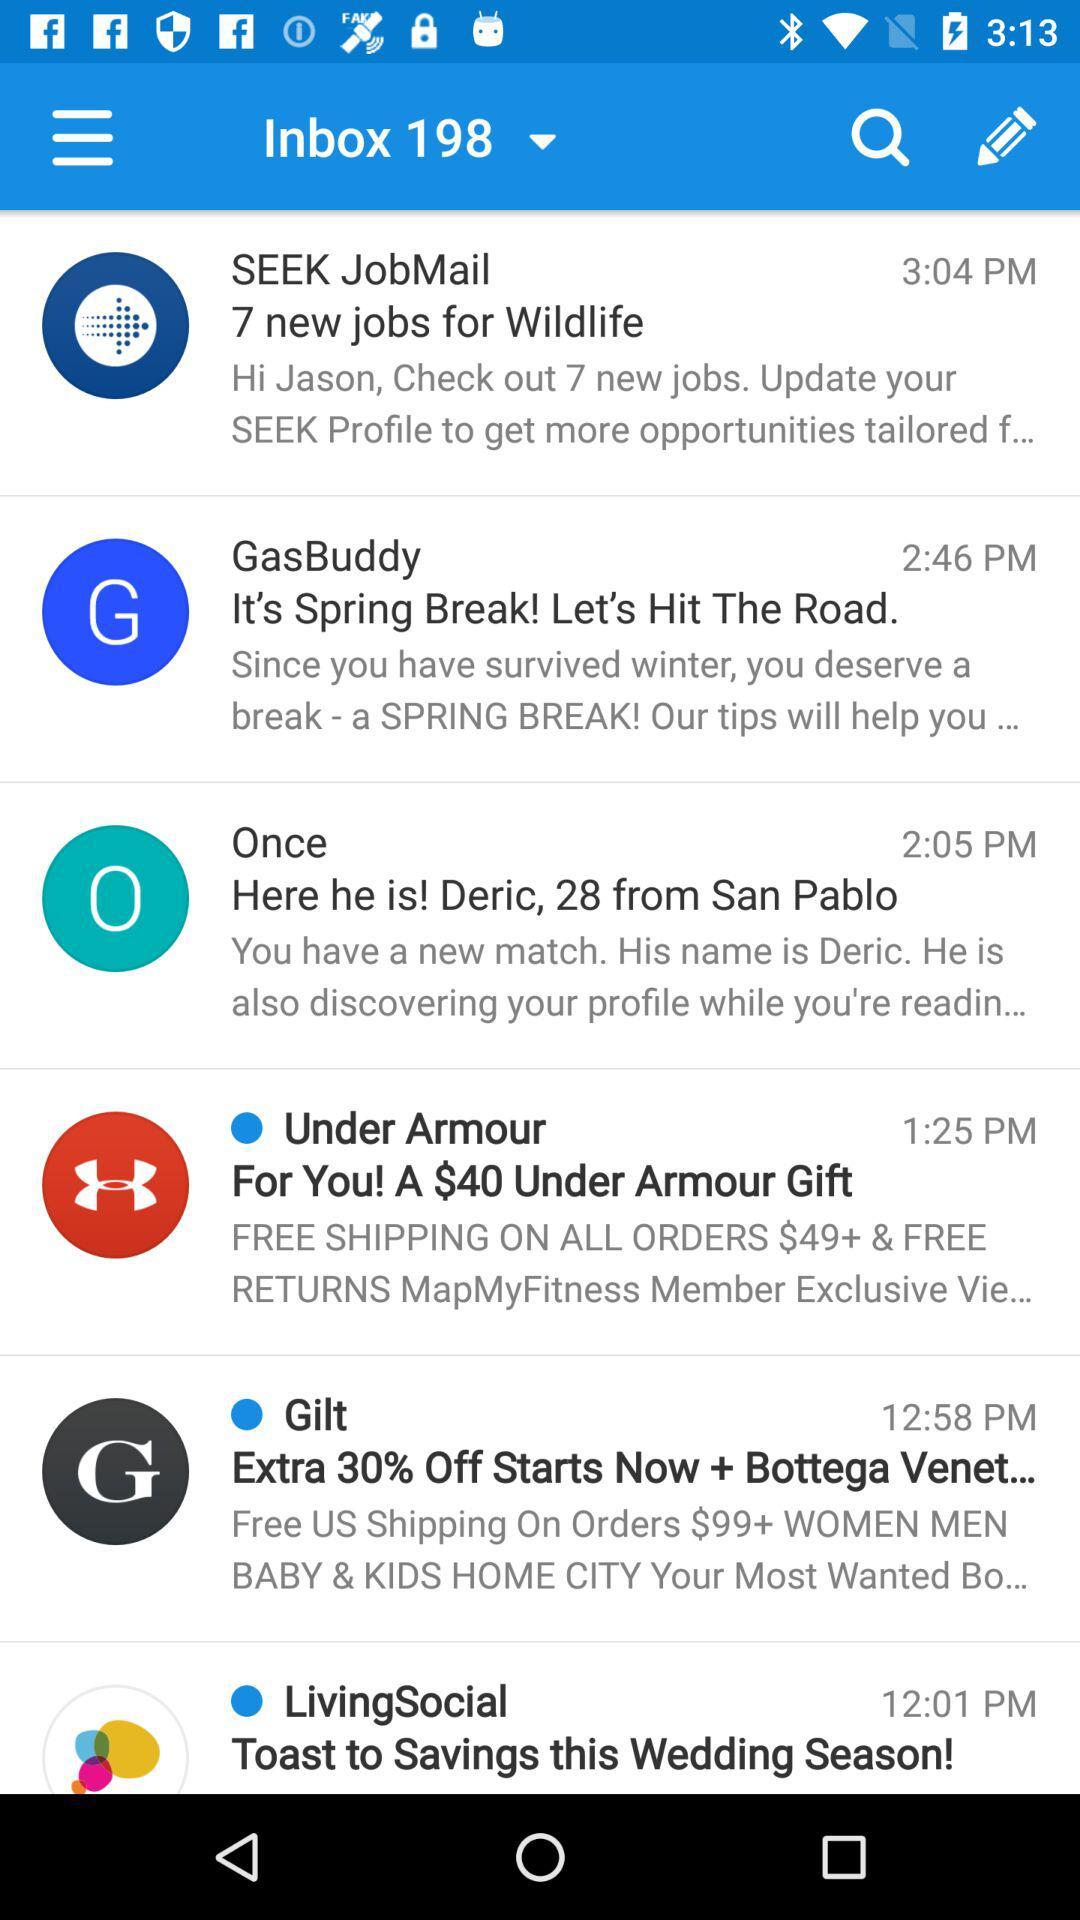When did you receive the email about Jobmail? The mail was received at 3:04 PM. 